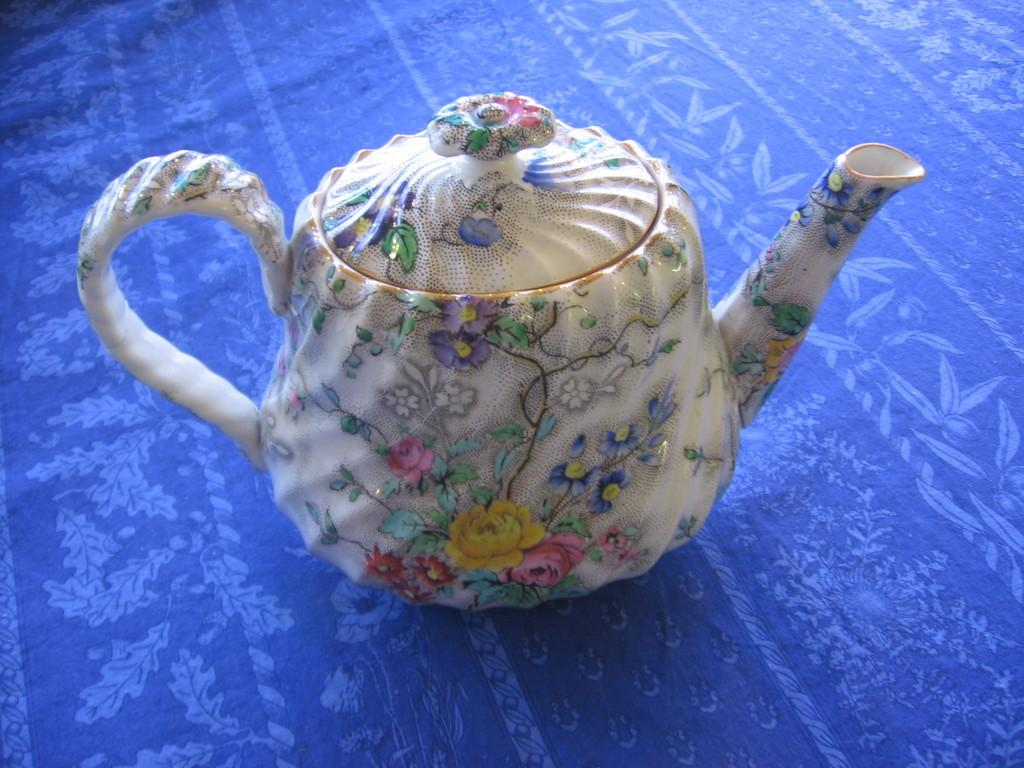What is the main object in the image? There is a kettle in the image. What is the kettle placed on? The kettle is on a blue color cloth. What design is visible on the kettle? The kettle has a design of flowers. What type of punishment is being administered to the kettle in the image? There is no punishment being administered to the kettle in the image; it is simply a kettle placed on a blue color cloth with a design of flowers. 